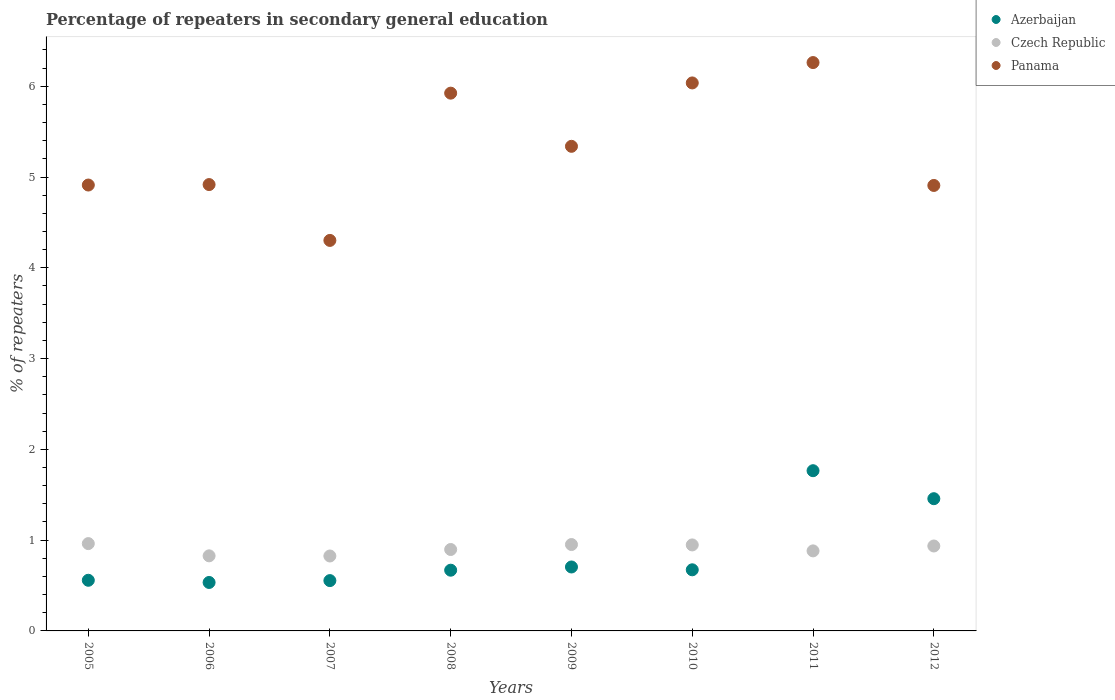Is the number of dotlines equal to the number of legend labels?
Ensure brevity in your answer.  Yes. What is the percentage of repeaters in secondary general education in Czech Republic in 2007?
Offer a very short reply. 0.83. Across all years, what is the maximum percentage of repeaters in secondary general education in Azerbaijan?
Your response must be concise. 1.77. Across all years, what is the minimum percentage of repeaters in secondary general education in Czech Republic?
Provide a succinct answer. 0.83. In which year was the percentage of repeaters in secondary general education in Azerbaijan maximum?
Offer a terse response. 2011. In which year was the percentage of repeaters in secondary general education in Czech Republic minimum?
Your response must be concise. 2007. What is the total percentage of repeaters in secondary general education in Czech Republic in the graph?
Your response must be concise. 7.23. What is the difference between the percentage of repeaters in secondary general education in Azerbaijan in 2007 and that in 2012?
Your answer should be very brief. -0.9. What is the difference between the percentage of repeaters in secondary general education in Czech Republic in 2006 and the percentage of repeaters in secondary general education in Panama in 2012?
Your response must be concise. -4.08. What is the average percentage of repeaters in secondary general education in Czech Republic per year?
Provide a short and direct response. 0.9. In the year 2011, what is the difference between the percentage of repeaters in secondary general education in Azerbaijan and percentage of repeaters in secondary general education in Czech Republic?
Give a very brief answer. 0.88. What is the ratio of the percentage of repeaters in secondary general education in Azerbaijan in 2008 to that in 2012?
Your answer should be compact. 0.46. Is the percentage of repeaters in secondary general education in Czech Republic in 2010 less than that in 2011?
Ensure brevity in your answer.  No. What is the difference between the highest and the second highest percentage of repeaters in secondary general education in Panama?
Offer a terse response. 0.22. What is the difference between the highest and the lowest percentage of repeaters in secondary general education in Panama?
Your answer should be very brief. 1.96. Is the sum of the percentage of repeaters in secondary general education in Azerbaijan in 2009 and 2011 greater than the maximum percentage of repeaters in secondary general education in Czech Republic across all years?
Ensure brevity in your answer.  Yes. Does the percentage of repeaters in secondary general education in Czech Republic monotonically increase over the years?
Keep it short and to the point. No. Is the percentage of repeaters in secondary general education in Panama strictly less than the percentage of repeaters in secondary general education in Azerbaijan over the years?
Your answer should be very brief. No. How many dotlines are there?
Provide a succinct answer. 3. How many years are there in the graph?
Your answer should be compact. 8. Are the values on the major ticks of Y-axis written in scientific E-notation?
Your answer should be very brief. No. Does the graph contain any zero values?
Your answer should be very brief. No. How are the legend labels stacked?
Keep it short and to the point. Vertical. What is the title of the graph?
Ensure brevity in your answer.  Percentage of repeaters in secondary general education. Does "Singapore" appear as one of the legend labels in the graph?
Offer a terse response. No. What is the label or title of the X-axis?
Provide a short and direct response. Years. What is the label or title of the Y-axis?
Offer a terse response. % of repeaters. What is the % of repeaters of Azerbaijan in 2005?
Provide a succinct answer. 0.56. What is the % of repeaters in Czech Republic in 2005?
Offer a terse response. 0.96. What is the % of repeaters in Panama in 2005?
Offer a very short reply. 4.91. What is the % of repeaters of Azerbaijan in 2006?
Offer a very short reply. 0.53. What is the % of repeaters of Czech Republic in 2006?
Make the answer very short. 0.83. What is the % of repeaters in Panama in 2006?
Your answer should be compact. 4.92. What is the % of repeaters of Azerbaijan in 2007?
Offer a terse response. 0.55. What is the % of repeaters in Czech Republic in 2007?
Offer a terse response. 0.83. What is the % of repeaters in Panama in 2007?
Your answer should be compact. 4.3. What is the % of repeaters of Azerbaijan in 2008?
Your answer should be compact. 0.67. What is the % of repeaters of Czech Republic in 2008?
Your answer should be very brief. 0.9. What is the % of repeaters of Panama in 2008?
Your answer should be very brief. 5.92. What is the % of repeaters in Azerbaijan in 2009?
Ensure brevity in your answer.  0.7. What is the % of repeaters in Czech Republic in 2009?
Your response must be concise. 0.95. What is the % of repeaters in Panama in 2009?
Offer a terse response. 5.34. What is the % of repeaters in Azerbaijan in 2010?
Your response must be concise. 0.67. What is the % of repeaters in Czech Republic in 2010?
Make the answer very short. 0.95. What is the % of repeaters of Panama in 2010?
Keep it short and to the point. 6.04. What is the % of repeaters of Azerbaijan in 2011?
Make the answer very short. 1.77. What is the % of repeaters of Czech Republic in 2011?
Make the answer very short. 0.88. What is the % of repeaters of Panama in 2011?
Provide a succinct answer. 6.26. What is the % of repeaters in Azerbaijan in 2012?
Provide a short and direct response. 1.46. What is the % of repeaters of Czech Republic in 2012?
Keep it short and to the point. 0.94. What is the % of repeaters of Panama in 2012?
Give a very brief answer. 4.91. Across all years, what is the maximum % of repeaters of Azerbaijan?
Offer a terse response. 1.77. Across all years, what is the maximum % of repeaters in Czech Republic?
Your response must be concise. 0.96. Across all years, what is the maximum % of repeaters in Panama?
Offer a very short reply. 6.26. Across all years, what is the minimum % of repeaters in Azerbaijan?
Make the answer very short. 0.53. Across all years, what is the minimum % of repeaters of Czech Republic?
Your answer should be very brief. 0.83. Across all years, what is the minimum % of repeaters in Panama?
Keep it short and to the point. 4.3. What is the total % of repeaters of Azerbaijan in the graph?
Provide a succinct answer. 6.91. What is the total % of repeaters in Czech Republic in the graph?
Ensure brevity in your answer.  7.23. What is the total % of repeaters in Panama in the graph?
Provide a succinct answer. 42.6. What is the difference between the % of repeaters in Azerbaijan in 2005 and that in 2006?
Your answer should be very brief. 0.02. What is the difference between the % of repeaters in Czech Republic in 2005 and that in 2006?
Provide a short and direct response. 0.13. What is the difference between the % of repeaters in Panama in 2005 and that in 2006?
Your answer should be compact. -0.01. What is the difference between the % of repeaters of Azerbaijan in 2005 and that in 2007?
Offer a very short reply. 0. What is the difference between the % of repeaters in Czech Republic in 2005 and that in 2007?
Offer a terse response. 0.14. What is the difference between the % of repeaters in Panama in 2005 and that in 2007?
Your response must be concise. 0.61. What is the difference between the % of repeaters of Azerbaijan in 2005 and that in 2008?
Make the answer very short. -0.11. What is the difference between the % of repeaters of Czech Republic in 2005 and that in 2008?
Keep it short and to the point. 0.07. What is the difference between the % of repeaters in Panama in 2005 and that in 2008?
Provide a succinct answer. -1.01. What is the difference between the % of repeaters in Azerbaijan in 2005 and that in 2009?
Your answer should be compact. -0.15. What is the difference between the % of repeaters of Czech Republic in 2005 and that in 2009?
Your response must be concise. 0.01. What is the difference between the % of repeaters of Panama in 2005 and that in 2009?
Give a very brief answer. -0.43. What is the difference between the % of repeaters in Azerbaijan in 2005 and that in 2010?
Make the answer very short. -0.12. What is the difference between the % of repeaters in Czech Republic in 2005 and that in 2010?
Offer a terse response. 0.01. What is the difference between the % of repeaters of Panama in 2005 and that in 2010?
Offer a terse response. -1.12. What is the difference between the % of repeaters of Azerbaijan in 2005 and that in 2011?
Make the answer very short. -1.21. What is the difference between the % of repeaters of Czech Republic in 2005 and that in 2011?
Keep it short and to the point. 0.08. What is the difference between the % of repeaters of Panama in 2005 and that in 2011?
Your response must be concise. -1.35. What is the difference between the % of repeaters of Azerbaijan in 2005 and that in 2012?
Keep it short and to the point. -0.9. What is the difference between the % of repeaters of Czech Republic in 2005 and that in 2012?
Offer a very short reply. 0.03. What is the difference between the % of repeaters of Panama in 2005 and that in 2012?
Your response must be concise. 0. What is the difference between the % of repeaters in Azerbaijan in 2006 and that in 2007?
Provide a succinct answer. -0.02. What is the difference between the % of repeaters of Czech Republic in 2006 and that in 2007?
Provide a succinct answer. 0. What is the difference between the % of repeaters of Panama in 2006 and that in 2007?
Keep it short and to the point. 0.62. What is the difference between the % of repeaters in Azerbaijan in 2006 and that in 2008?
Offer a terse response. -0.14. What is the difference between the % of repeaters of Czech Republic in 2006 and that in 2008?
Provide a short and direct response. -0.07. What is the difference between the % of repeaters in Panama in 2006 and that in 2008?
Offer a very short reply. -1.01. What is the difference between the % of repeaters of Azerbaijan in 2006 and that in 2009?
Give a very brief answer. -0.17. What is the difference between the % of repeaters of Czech Republic in 2006 and that in 2009?
Give a very brief answer. -0.12. What is the difference between the % of repeaters of Panama in 2006 and that in 2009?
Your answer should be compact. -0.42. What is the difference between the % of repeaters in Azerbaijan in 2006 and that in 2010?
Provide a short and direct response. -0.14. What is the difference between the % of repeaters in Czech Republic in 2006 and that in 2010?
Provide a succinct answer. -0.12. What is the difference between the % of repeaters in Panama in 2006 and that in 2010?
Keep it short and to the point. -1.12. What is the difference between the % of repeaters of Azerbaijan in 2006 and that in 2011?
Your answer should be compact. -1.23. What is the difference between the % of repeaters of Czech Republic in 2006 and that in 2011?
Ensure brevity in your answer.  -0.05. What is the difference between the % of repeaters of Panama in 2006 and that in 2011?
Provide a succinct answer. -1.34. What is the difference between the % of repeaters in Azerbaijan in 2006 and that in 2012?
Offer a very short reply. -0.92. What is the difference between the % of repeaters of Czech Republic in 2006 and that in 2012?
Keep it short and to the point. -0.11. What is the difference between the % of repeaters in Panama in 2006 and that in 2012?
Ensure brevity in your answer.  0.01. What is the difference between the % of repeaters in Azerbaijan in 2007 and that in 2008?
Offer a terse response. -0.11. What is the difference between the % of repeaters of Czech Republic in 2007 and that in 2008?
Provide a succinct answer. -0.07. What is the difference between the % of repeaters of Panama in 2007 and that in 2008?
Make the answer very short. -1.62. What is the difference between the % of repeaters of Azerbaijan in 2007 and that in 2009?
Your response must be concise. -0.15. What is the difference between the % of repeaters in Czech Republic in 2007 and that in 2009?
Keep it short and to the point. -0.13. What is the difference between the % of repeaters in Panama in 2007 and that in 2009?
Your answer should be compact. -1.04. What is the difference between the % of repeaters in Azerbaijan in 2007 and that in 2010?
Provide a succinct answer. -0.12. What is the difference between the % of repeaters of Czech Republic in 2007 and that in 2010?
Provide a succinct answer. -0.12. What is the difference between the % of repeaters in Panama in 2007 and that in 2010?
Ensure brevity in your answer.  -1.74. What is the difference between the % of repeaters of Azerbaijan in 2007 and that in 2011?
Provide a short and direct response. -1.21. What is the difference between the % of repeaters in Czech Republic in 2007 and that in 2011?
Offer a terse response. -0.06. What is the difference between the % of repeaters in Panama in 2007 and that in 2011?
Make the answer very short. -1.96. What is the difference between the % of repeaters in Azerbaijan in 2007 and that in 2012?
Keep it short and to the point. -0.9. What is the difference between the % of repeaters in Czech Republic in 2007 and that in 2012?
Provide a short and direct response. -0.11. What is the difference between the % of repeaters in Panama in 2007 and that in 2012?
Your response must be concise. -0.61. What is the difference between the % of repeaters of Azerbaijan in 2008 and that in 2009?
Provide a succinct answer. -0.04. What is the difference between the % of repeaters in Czech Republic in 2008 and that in 2009?
Offer a very short reply. -0.05. What is the difference between the % of repeaters of Panama in 2008 and that in 2009?
Provide a succinct answer. 0.59. What is the difference between the % of repeaters in Azerbaijan in 2008 and that in 2010?
Ensure brevity in your answer.  -0. What is the difference between the % of repeaters of Czech Republic in 2008 and that in 2010?
Provide a short and direct response. -0.05. What is the difference between the % of repeaters of Panama in 2008 and that in 2010?
Ensure brevity in your answer.  -0.11. What is the difference between the % of repeaters in Azerbaijan in 2008 and that in 2011?
Make the answer very short. -1.1. What is the difference between the % of repeaters of Czech Republic in 2008 and that in 2011?
Offer a very short reply. 0.02. What is the difference between the % of repeaters of Panama in 2008 and that in 2011?
Ensure brevity in your answer.  -0.34. What is the difference between the % of repeaters in Azerbaijan in 2008 and that in 2012?
Your answer should be very brief. -0.79. What is the difference between the % of repeaters of Czech Republic in 2008 and that in 2012?
Make the answer very short. -0.04. What is the difference between the % of repeaters in Panama in 2008 and that in 2012?
Your answer should be compact. 1.02. What is the difference between the % of repeaters of Azerbaijan in 2009 and that in 2010?
Provide a short and direct response. 0.03. What is the difference between the % of repeaters in Czech Republic in 2009 and that in 2010?
Offer a terse response. 0. What is the difference between the % of repeaters in Panama in 2009 and that in 2010?
Make the answer very short. -0.7. What is the difference between the % of repeaters in Azerbaijan in 2009 and that in 2011?
Provide a short and direct response. -1.06. What is the difference between the % of repeaters in Czech Republic in 2009 and that in 2011?
Ensure brevity in your answer.  0.07. What is the difference between the % of repeaters of Panama in 2009 and that in 2011?
Make the answer very short. -0.92. What is the difference between the % of repeaters of Azerbaijan in 2009 and that in 2012?
Give a very brief answer. -0.75. What is the difference between the % of repeaters in Czech Republic in 2009 and that in 2012?
Your response must be concise. 0.02. What is the difference between the % of repeaters of Panama in 2009 and that in 2012?
Offer a very short reply. 0.43. What is the difference between the % of repeaters of Azerbaijan in 2010 and that in 2011?
Provide a succinct answer. -1.09. What is the difference between the % of repeaters in Czech Republic in 2010 and that in 2011?
Offer a very short reply. 0.07. What is the difference between the % of repeaters in Panama in 2010 and that in 2011?
Offer a very short reply. -0.22. What is the difference between the % of repeaters in Azerbaijan in 2010 and that in 2012?
Your answer should be compact. -0.78. What is the difference between the % of repeaters of Czech Republic in 2010 and that in 2012?
Your answer should be very brief. 0.01. What is the difference between the % of repeaters of Panama in 2010 and that in 2012?
Offer a terse response. 1.13. What is the difference between the % of repeaters in Azerbaijan in 2011 and that in 2012?
Offer a terse response. 0.31. What is the difference between the % of repeaters of Czech Republic in 2011 and that in 2012?
Offer a very short reply. -0.05. What is the difference between the % of repeaters of Panama in 2011 and that in 2012?
Keep it short and to the point. 1.35. What is the difference between the % of repeaters of Azerbaijan in 2005 and the % of repeaters of Czech Republic in 2006?
Ensure brevity in your answer.  -0.27. What is the difference between the % of repeaters in Azerbaijan in 2005 and the % of repeaters in Panama in 2006?
Keep it short and to the point. -4.36. What is the difference between the % of repeaters in Czech Republic in 2005 and the % of repeaters in Panama in 2006?
Ensure brevity in your answer.  -3.96. What is the difference between the % of repeaters in Azerbaijan in 2005 and the % of repeaters in Czech Republic in 2007?
Give a very brief answer. -0.27. What is the difference between the % of repeaters in Azerbaijan in 2005 and the % of repeaters in Panama in 2007?
Your answer should be very brief. -3.74. What is the difference between the % of repeaters of Czech Republic in 2005 and the % of repeaters of Panama in 2007?
Make the answer very short. -3.34. What is the difference between the % of repeaters of Azerbaijan in 2005 and the % of repeaters of Czech Republic in 2008?
Make the answer very short. -0.34. What is the difference between the % of repeaters in Azerbaijan in 2005 and the % of repeaters in Panama in 2008?
Make the answer very short. -5.37. What is the difference between the % of repeaters of Czech Republic in 2005 and the % of repeaters of Panama in 2008?
Ensure brevity in your answer.  -4.96. What is the difference between the % of repeaters in Azerbaijan in 2005 and the % of repeaters in Czech Republic in 2009?
Ensure brevity in your answer.  -0.39. What is the difference between the % of repeaters in Azerbaijan in 2005 and the % of repeaters in Panama in 2009?
Give a very brief answer. -4.78. What is the difference between the % of repeaters in Czech Republic in 2005 and the % of repeaters in Panama in 2009?
Your answer should be very brief. -4.38. What is the difference between the % of repeaters in Azerbaijan in 2005 and the % of repeaters in Czech Republic in 2010?
Ensure brevity in your answer.  -0.39. What is the difference between the % of repeaters of Azerbaijan in 2005 and the % of repeaters of Panama in 2010?
Provide a short and direct response. -5.48. What is the difference between the % of repeaters of Czech Republic in 2005 and the % of repeaters of Panama in 2010?
Make the answer very short. -5.08. What is the difference between the % of repeaters of Azerbaijan in 2005 and the % of repeaters of Czech Republic in 2011?
Offer a very short reply. -0.32. What is the difference between the % of repeaters of Azerbaijan in 2005 and the % of repeaters of Panama in 2011?
Offer a terse response. -5.7. What is the difference between the % of repeaters of Czech Republic in 2005 and the % of repeaters of Panama in 2011?
Your answer should be compact. -5.3. What is the difference between the % of repeaters of Azerbaijan in 2005 and the % of repeaters of Czech Republic in 2012?
Your response must be concise. -0.38. What is the difference between the % of repeaters in Azerbaijan in 2005 and the % of repeaters in Panama in 2012?
Your response must be concise. -4.35. What is the difference between the % of repeaters in Czech Republic in 2005 and the % of repeaters in Panama in 2012?
Offer a terse response. -3.95. What is the difference between the % of repeaters in Azerbaijan in 2006 and the % of repeaters in Czech Republic in 2007?
Keep it short and to the point. -0.29. What is the difference between the % of repeaters in Azerbaijan in 2006 and the % of repeaters in Panama in 2007?
Ensure brevity in your answer.  -3.77. What is the difference between the % of repeaters of Czech Republic in 2006 and the % of repeaters of Panama in 2007?
Offer a terse response. -3.48. What is the difference between the % of repeaters in Azerbaijan in 2006 and the % of repeaters in Czech Republic in 2008?
Your answer should be compact. -0.36. What is the difference between the % of repeaters of Azerbaijan in 2006 and the % of repeaters of Panama in 2008?
Offer a very short reply. -5.39. What is the difference between the % of repeaters in Czech Republic in 2006 and the % of repeaters in Panama in 2008?
Provide a succinct answer. -5.1. What is the difference between the % of repeaters in Azerbaijan in 2006 and the % of repeaters in Czech Republic in 2009?
Your answer should be very brief. -0.42. What is the difference between the % of repeaters in Azerbaijan in 2006 and the % of repeaters in Panama in 2009?
Offer a very short reply. -4.8. What is the difference between the % of repeaters of Czech Republic in 2006 and the % of repeaters of Panama in 2009?
Your response must be concise. -4.51. What is the difference between the % of repeaters of Azerbaijan in 2006 and the % of repeaters of Czech Republic in 2010?
Your answer should be very brief. -0.41. What is the difference between the % of repeaters in Azerbaijan in 2006 and the % of repeaters in Panama in 2010?
Offer a very short reply. -5.5. What is the difference between the % of repeaters in Czech Republic in 2006 and the % of repeaters in Panama in 2010?
Provide a short and direct response. -5.21. What is the difference between the % of repeaters of Azerbaijan in 2006 and the % of repeaters of Czech Republic in 2011?
Provide a succinct answer. -0.35. What is the difference between the % of repeaters of Azerbaijan in 2006 and the % of repeaters of Panama in 2011?
Provide a short and direct response. -5.73. What is the difference between the % of repeaters of Czech Republic in 2006 and the % of repeaters of Panama in 2011?
Ensure brevity in your answer.  -5.43. What is the difference between the % of repeaters in Azerbaijan in 2006 and the % of repeaters in Czech Republic in 2012?
Provide a short and direct response. -0.4. What is the difference between the % of repeaters of Azerbaijan in 2006 and the % of repeaters of Panama in 2012?
Give a very brief answer. -4.37. What is the difference between the % of repeaters in Czech Republic in 2006 and the % of repeaters in Panama in 2012?
Offer a very short reply. -4.08. What is the difference between the % of repeaters in Azerbaijan in 2007 and the % of repeaters in Czech Republic in 2008?
Your answer should be compact. -0.34. What is the difference between the % of repeaters of Azerbaijan in 2007 and the % of repeaters of Panama in 2008?
Give a very brief answer. -5.37. What is the difference between the % of repeaters in Czech Republic in 2007 and the % of repeaters in Panama in 2008?
Provide a short and direct response. -5.1. What is the difference between the % of repeaters in Azerbaijan in 2007 and the % of repeaters in Czech Republic in 2009?
Offer a very short reply. -0.4. What is the difference between the % of repeaters of Azerbaijan in 2007 and the % of repeaters of Panama in 2009?
Provide a succinct answer. -4.78. What is the difference between the % of repeaters in Czech Republic in 2007 and the % of repeaters in Panama in 2009?
Ensure brevity in your answer.  -4.51. What is the difference between the % of repeaters of Azerbaijan in 2007 and the % of repeaters of Czech Republic in 2010?
Give a very brief answer. -0.39. What is the difference between the % of repeaters in Azerbaijan in 2007 and the % of repeaters in Panama in 2010?
Make the answer very short. -5.48. What is the difference between the % of repeaters in Czech Republic in 2007 and the % of repeaters in Panama in 2010?
Make the answer very short. -5.21. What is the difference between the % of repeaters in Azerbaijan in 2007 and the % of repeaters in Czech Republic in 2011?
Make the answer very short. -0.33. What is the difference between the % of repeaters in Azerbaijan in 2007 and the % of repeaters in Panama in 2011?
Offer a very short reply. -5.71. What is the difference between the % of repeaters in Czech Republic in 2007 and the % of repeaters in Panama in 2011?
Your answer should be very brief. -5.44. What is the difference between the % of repeaters of Azerbaijan in 2007 and the % of repeaters of Czech Republic in 2012?
Provide a short and direct response. -0.38. What is the difference between the % of repeaters in Azerbaijan in 2007 and the % of repeaters in Panama in 2012?
Provide a short and direct response. -4.35. What is the difference between the % of repeaters in Czech Republic in 2007 and the % of repeaters in Panama in 2012?
Offer a terse response. -4.08. What is the difference between the % of repeaters in Azerbaijan in 2008 and the % of repeaters in Czech Republic in 2009?
Give a very brief answer. -0.28. What is the difference between the % of repeaters in Azerbaijan in 2008 and the % of repeaters in Panama in 2009?
Provide a succinct answer. -4.67. What is the difference between the % of repeaters of Czech Republic in 2008 and the % of repeaters of Panama in 2009?
Your answer should be very brief. -4.44. What is the difference between the % of repeaters of Azerbaijan in 2008 and the % of repeaters of Czech Republic in 2010?
Your answer should be very brief. -0.28. What is the difference between the % of repeaters in Azerbaijan in 2008 and the % of repeaters in Panama in 2010?
Provide a short and direct response. -5.37. What is the difference between the % of repeaters in Czech Republic in 2008 and the % of repeaters in Panama in 2010?
Your answer should be very brief. -5.14. What is the difference between the % of repeaters of Azerbaijan in 2008 and the % of repeaters of Czech Republic in 2011?
Give a very brief answer. -0.21. What is the difference between the % of repeaters of Azerbaijan in 2008 and the % of repeaters of Panama in 2011?
Make the answer very short. -5.59. What is the difference between the % of repeaters of Czech Republic in 2008 and the % of repeaters of Panama in 2011?
Your answer should be very brief. -5.36. What is the difference between the % of repeaters of Azerbaijan in 2008 and the % of repeaters of Czech Republic in 2012?
Your response must be concise. -0.27. What is the difference between the % of repeaters of Azerbaijan in 2008 and the % of repeaters of Panama in 2012?
Make the answer very short. -4.24. What is the difference between the % of repeaters in Czech Republic in 2008 and the % of repeaters in Panama in 2012?
Your answer should be compact. -4.01. What is the difference between the % of repeaters of Azerbaijan in 2009 and the % of repeaters of Czech Republic in 2010?
Provide a succinct answer. -0.24. What is the difference between the % of repeaters of Azerbaijan in 2009 and the % of repeaters of Panama in 2010?
Offer a terse response. -5.33. What is the difference between the % of repeaters of Czech Republic in 2009 and the % of repeaters of Panama in 2010?
Give a very brief answer. -5.09. What is the difference between the % of repeaters in Azerbaijan in 2009 and the % of repeaters in Czech Republic in 2011?
Provide a short and direct response. -0.18. What is the difference between the % of repeaters of Azerbaijan in 2009 and the % of repeaters of Panama in 2011?
Make the answer very short. -5.56. What is the difference between the % of repeaters in Czech Republic in 2009 and the % of repeaters in Panama in 2011?
Make the answer very short. -5.31. What is the difference between the % of repeaters in Azerbaijan in 2009 and the % of repeaters in Czech Republic in 2012?
Offer a terse response. -0.23. What is the difference between the % of repeaters of Azerbaijan in 2009 and the % of repeaters of Panama in 2012?
Provide a succinct answer. -4.2. What is the difference between the % of repeaters in Czech Republic in 2009 and the % of repeaters in Panama in 2012?
Provide a succinct answer. -3.96. What is the difference between the % of repeaters of Azerbaijan in 2010 and the % of repeaters of Czech Republic in 2011?
Offer a terse response. -0.21. What is the difference between the % of repeaters of Azerbaijan in 2010 and the % of repeaters of Panama in 2011?
Keep it short and to the point. -5.59. What is the difference between the % of repeaters of Czech Republic in 2010 and the % of repeaters of Panama in 2011?
Offer a terse response. -5.31. What is the difference between the % of repeaters of Azerbaijan in 2010 and the % of repeaters of Czech Republic in 2012?
Your response must be concise. -0.26. What is the difference between the % of repeaters of Azerbaijan in 2010 and the % of repeaters of Panama in 2012?
Your response must be concise. -4.23. What is the difference between the % of repeaters of Czech Republic in 2010 and the % of repeaters of Panama in 2012?
Keep it short and to the point. -3.96. What is the difference between the % of repeaters in Azerbaijan in 2011 and the % of repeaters in Czech Republic in 2012?
Provide a short and direct response. 0.83. What is the difference between the % of repeaters of Azerbaijan in 2011 and the % of repeaters of Panama in 2012?
Give a very brief answer. -3.14. What is the difference between the % of repeaters of Czech Republic in 2011 and the % of repeaters of Panama in 2012?
Your answer should be very brief. -4.03. What is the average % of repeaters in Azerbaijan per year?
Provide a short and direct response. 0.86. What is the average % of repeaters of Czech Republic per year?
Ensure brevity in your answer.  0.9. What is the average % of repeaters of Panama per year?
Provide a succinct answer. 5.33. In the year 2005, what is the difference between the % of repeaters in Azerbaijan and % of repeaters in Czech Republic?
Your answer should be compact. -0.4. In the year 2005, what is the difference between the % of repeaters of Azerbaijan and % of repeaters of Panama?
Provide a short and direct response. -4.35. In the year 2005, what is the difference between the % of repeaters of Czech Republic and % of repeaters of Panama?
Your response must be concise. -3.95. In the year 2006, what is the difference between the % of repeaters in Azerbaijan and % of repeaters in Czech Republic?
Your answer should be very brief. -0.29. In the year 2006, what is the difference between the % of repeaters of Azerbaijan and % of repeaters of Panama?
Make the answer very short. -4.38. In the year 2006, what is the difference between the % of repeaters of Czech Republic and % of repeaters of Panama?
Ensure brevity in your answer.  -4.09. In the year 2007, what is the difference between the % of repeaters of Azerbaijan and % of repeaters of Czech Republic?
Provide a short and direct response. -0.27. In the year 2007, what is the difference between the % of repeaters of Azerbaijan and % of repeaters of Panama?
Your response must be concise. -3.75. In the year 2007, what is the difference between the % of repeaters of Czech Republic and % of repeaters of Panama?
Make the answer very short. -3.48. In the year 2008, what is the difference between the % of repeaters of Azerbaijan and % of repeaters of Czech Republic?
Offer a very short reply. -0.23. In the year 2008, what is the difference between the % of repeaters of Azerbaijan and % of repeaters of Panama?
Offer a very short reply. -5.26. In the year 2008, what is the difference between the % of repeaters in Czech Republic and % of repeaters in Panama?
Your response must be concise. -5.03. In the year 2009, what is the difference between the % of repeaters of Azerbaijan and % of repeaters of Czech Republic?
Your answer should be compact. -0.25. In the year 2009, what is the difference between the % of repeaters in Azerbaijan and % of repeaters in Panama?
Keep it short and to the point. -4.63. In the year 2009, what is the difference between the % of repeaters in Czech Republic and % of repeaters in Panama?
Make the answer very short. -4.39. In the year 2010, what is the difference between the % of repeaters of Azerbaijan and % of repeaters of Czech Republic?
Make the answer very short. -0.27. In the year 2010, what is the difference between the % of repeaters in Azerbaijan and % of repeaters in Panama?
Ensure brevity in your answer.  -5.36. In the year 2010, what is the difference between the % of repeaters of Czech Republic and % of repeaters of Panama?
Give a very brief answer. -5.09. In the year 2011, what is the difference between the % of repeaters in Azerbaijan and % of repeaters in Czech Republic?
Your response must be concise. 0.88. In the year 2011, what is the difference between the % of repeaters in Azerbaijan and % of repeaters in Panama?
Provide a short and direct response. -4.5. In the year 2011, what is the difference between the % of repeaters in Czech Republic and % of repeaters in Panama?
Your answer should be very brief. -5.38. In the year 2012, what is the difference between the % of repeaters in Azerbaijan and % of repeaters in Czech Republic?
Your response must be concise. 0.52. In the year 2012, what is the difference between the % of repeaters in Azerbaijan and % of repeaters in Panama?
Your answer should be compact. -3.45. In the year 2012, what is the difference between the % of repeaters of Czech Republic and % of repeaters of Panama?
Your answer should be very brief. -3.97. What is the ratio of the % of repeaters in Azerbaijan in 2005 to that in 2006?
Offer a terse response. 1.05. What is the ratio of the % of repeaters in Czech Republic in 2005 to that in 2006?
Offer a very short reply. 1.16. What is the ratio of the % of repeaters of Azerbaijan in 2005 to that in 2007?
Offer a terse response. 1.01. What is the ratio of the % of repeaters of Czech Republic in 2005 to that in 2007?
Provide a succinct answer. 1.17. What is the ratio of the % of repeaters of Panama in 2005 to that in 2007?
Make the answer very short. 1.14. What is the ratio of the % of repeaters of Azerbaijan in 2005 to that in 2008?
Give a very brief answer. 0.83. What is the ratio of the % of repeaters of Czech Republic in 2005 to that in 2008?
Your response must be concise. 1.07. What is the ratio of the % of repeaters in Panama in 2005 to that in 2008?
Ensure brevity in your answer.  0.83. What is the ratio of the % of repeaters of Azerbaijan in 2005 to that in 2009?
Keep it short and to the point. 0.79. What is the ratio of the % of repeaters in Czech Republic in 2005 to that in 2009?
Provide a succinct answer. 1.01. What is the ratio of the % of repeaters in Panama in 2005 to that in 2009?
Your response must be concise. 0.92. What is the ratio of the % of repeaters in Azerbaijan in 2005 to that in 2010?
Provide a short and direct response. 0.83. What is the ratio of the % of repeaters in Czech Republic in 2005 to that in 2010?
Offer a very short reply. 1.02. What is the ratio of the % of repeaters in Panama in 2005 to that in 2010?
Your answer should be very brief. 0.81. What is the ratio of the % of repeaters of Azerbaijan in 2005 to that in 2011?
Give a very brief answer. 0.32. What is the ratio of the % of repeaters of Czech Republic in 2005 to that in 2011?
Offer a very short reply. 1.09. What is the ratio of the % of repeaters in Panama in 2005 to that in 2011?
Provide a short and direct response. 0.78. What is the ratio of the % of repeaters of Azerbaijan in 2005 to that in 2012?
Make the answer very short. 0.38. What is the ratio of the % of repeaters of Czech Republic in 2005 to that in 2012?
Offer a very short reply. 1.03. What is the ratio of the % of repeaters of Azerbaijan in 2006 to that in 2007?
Your response must be concise. 0.96. What is the ratio of the % of repeaters of Czech Republic in 2006 to that in 2007?
Offer a terse response. 1. What is the ratio of the % of repeaters of Panama in 2006 to that in 2007?
Your answer should be compact. 1.14. What is the ratio of the % of repeaters of Azerbaijan in 2006 to that in 2008?
Your response must be concise. 0.8. What is the ratio of the % of repeaters of Czech Republic in 2006 to that in 2008?
Make the answer very short. 0.92. What is the ratio of the % of repeaters of Panama in 2006 to that in 2008?
Provide a short and direct response. 0.83. What is the ratio of the % of repeaters of Azerbaijan in 2006 to that in 2009?
Keep it short and to the point. 0.76. What is the ratio of the % of repeaters in Czech Republic in 2006 to that in 2009?
Provide a succinct answer. 0.87. What is the ratio of the % of repeaters of Panama in 2006 to that in 2009?
Make the answer very short. 0.92. What is the ratio of the % of repeaters in Azerbaijan in 2006 to that in 2010?
Ensure brevity in your answer.  0.79. What is the ratio of the % of repeaters of Czech Republic in 2006 to that in 2010?
Ensure brevity in your answer.  0.87. What is the ratio of the % of repeaters of Panama in 2006 to that in 2010?
Provide a short and direct response. 0.81. What is the ratio of the % of repeaters of Azerbaijan in 2006 to that in 2011?
Keep it short and to the point. 0.3. What is the ratio of the % of repeaters of Czech Republic in 2006 to that in 2011?
Give a very brief answer. 0.94. What is the ratio of the % of repeaters in Panama in 2006 to that in 2011?
Provide a succinct answer. 0.79. What is the ratio of the % of repeaters in Azerbaijan in 2006 to that in 2012?
Provide a short and direct response. 0.37. What is the ratio of the % of repeaters in Czech Republic in 2006 to that in 2012?
Offer a very short reply. 0.88. What is the ratio of the % of repeaters of Azerbaijan in 2007 to that in 2008?
Your answer should be compact. 0.83. What is the ratio of the % of repeaters of Czech Republic in 2007 to that in 2008?
Offer a very short reply. 0.92. What is the ratio of the % of repeaters of Panama in 2007 to that in 2008?
Provide a succinct answer. 0.73. What is the ratio of the % of repeaters in Azerbaijan in 2007 to that in 2009?
Your answer should be compact. 0.79. What is the ratio of the % of repeaters in Czech Republic in 2007 to that in 2009?
Ensure brevity in your answer.  0.87. What is the ratio of the % of repeaters of Panama in 2007 to that in 2009?
Ensure brevity in your answer.  0.81. What is the ratio of the % of repeaters of Azerbaijan in 2007 to that in 2010?
Ensure brevity in your answer.  0.82. What is the ratio of the % of repeaters of Czech Republic in 2007 to that in 2010?
Your answer should be very brief. 0.87. What is the ratio of the % of repeaters in Panama in 2007 to that in 2010?
Offer a terse response. 0.71. What is the ratio of the % of repeaters in Azerbaijan in 2007 to that in 2011?
Give a very brief answer. 0.31. What is the ratio of the % of repeaters of Czech Republic in 2007 to that in 2011?
Give a very brief answer. 0.94. What is the ratio of the % of repeaters in Panama in 2007 to that in 2011?
Provide a short and direct response. 0.69. What is the ratio of the % of repeaters in Azerbaijan in 2007 to that in 2012?
Provide a short and direct response. 0.38. What is the ratio of the % of repeaters in Czech Republic in 2007 to that in 2012?
Provide a succinct answer. 0.88. What is the ratio of the % of repeaters of Panama in 2007 to that in 2012?
Provide a short and direct response. 0.88. What is the ratio of the % of repeaters in Azerbaijan in 2008 to that in 2009?
Your answer should be compact. 0.95. What is the ratio of the % of repeaters in Czech Republic in 2008 to that in 2009?
Make the answer very short. 0.94. What is the ratio of the % of repeaters of Panama in 2008 to that in 2009?
Give a very brief answer. 1.11. What is the ratio of the % of repeaters in Azerbaijan in 2008 to that in 2010?
Your response must be concise. 0.99. What is the ratio of the % of repeaters of Czech Republic in 2008 to that in 2010?
Your answer should be compact. 0.95. What is the ratio of the % of repeaters in Panama in 2008 to that in 2010?
Offer a terse response. 0.98. What is the ratio of the % of repeaters in Azerbaijan in 2008 to that in 2011?
Offer a terse response. 0.38. What is the ratio of the % of repeaters of Czech Republic in 2008 to that in 2011?
Keep it short and to the point. 1.02. What is the ratio of the % of repeaters in Panama in 2008 to that in 2011?
Offer a terse response. 0.95. What is the ratio of the % of repeaters in Azerbaijan in 2008 to that in 2012?
Keep it short and to the point. 0.46. What is the ratio of the % of repeaters of Czech Republic in 2008 to that in 2012?
Provide a succinct answer. 0.96. What is the ratio of the % of repeaters of Panama in 2008 to that in 2012?
Your answer should be very brief. 1.21. What is the ratio of the % of repeaters of Azerbaijan in 2009 to that in 2010?
Offer a very short reply. 1.05. What is the ratio of the % of repeaters in Czech Republic in 2009 to that in 2010?
Keep it short and to the point. 1. What is the ratio of the % of repeaters in Panama in 2009 to that in 2010?
Give a very brief answer. 0.88. What is the ratio of the % of repeaters of Azerbaijan in 2009 to that in 2011?
Provide a short and direct response. 0.4. What is the ratio of the % of repeaters in Czech Republic in 2009 to that in 2011?
Provide a succinct answer. 1.08. What is the ratio of the % of repeaters in Panama in 2009 to that in 2011?
Your answer should be very brief. 0.85. What is the ratio of the % of repeaters in Azerbaijan in 2009 to that in 2012?
Keep it short and to the point. 0.48. What is the ratio of the % of repeaters of Czech Republic in 2009 to that in 2012?
Your response must be concise. 1.02. What is the ratio of the % of repeaters of Panama in 2009 to that in 2012?
Offer a terse response. 1.09. What is the ratio of the % of repeaters of Azerbaijan in 2010 to that in 2011?
Your response must be concise. 0.38. What is the ratio of the % of repeaters in Czech Republic in 2010 to that in 2011?
Make the answer very short. 1.07. What is the ratio of the % of repeaters of Panama in 2010 to that in 2011?
Offer a terse response. 0.96. What is the ratio of the % of repeaters of Azerbaijan in 2010 to that in 2012?
Your response must be concise. 0.46. What is the ratio of the % of repeaters of Czech Republic in 2010 to that in 2012?
Offer a very short reply. 1.01. What is the ratio of the % of repeaters of Panama in 2010 to that in 2012?
Offer a terse response. 1.23. What is the ratio of the % of repeaters in Azerbaijan in 2011 to that in 2012?
Your answer should be very brief. 1.21. What is the ratio of the % of repeaters in Czech Republic in 2011 to that in 2012?
Make the answer very short. 0.94. What is the ratio of the % of repeaters of Panama in 2011 to that in 2012?
Make the answer very short. 1.28. What is the difference between the highest and the second highest % of repeaters of Azerbaijan?
Provide a succinct answer. 0.31. What is the difference between the highest and the second highest % of repeaters in Czech Republic?
Give a very brief answer. 0.01. What is the difference between the highest and the second highest % of repeaters in Panama?
Provide a short and direct response. 0.22. What is the difference between the highest and the lowest % of repeaters in Azerbaijan?
Make the answer very short. 1.23. What is the difference between the highest and the lowest % of repeaters in Czech Republic?
Make the answer very short. 0.14. What is the difference between the highest and the lowest % of repeaters of Panama?
Provide a succinct answer. 1.96. 